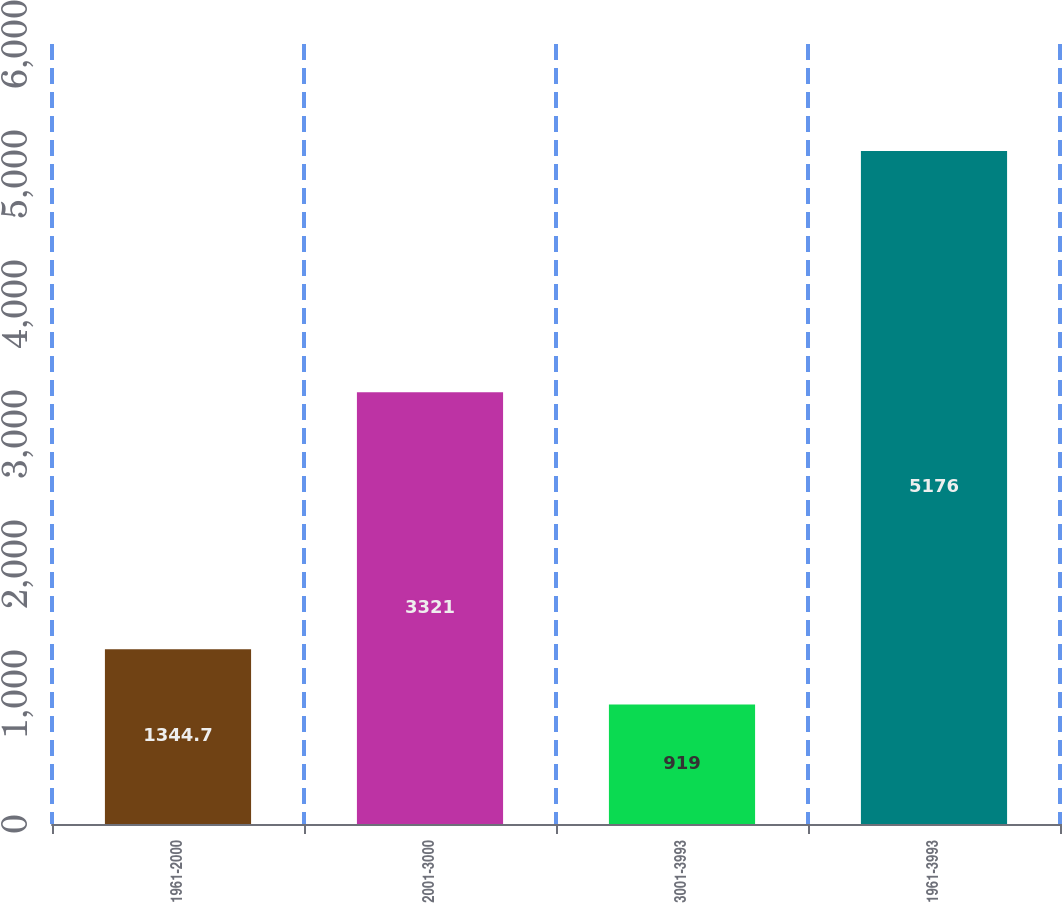<chart> <loc_0><loc_0><loc_500><loc_500><bar_chart><fcel>1961-2000<fcel>2001-3000<fcel>3001-3993<fcel>1961-3993<nl><fcel>1344.7<fcel>3321<fcel>919<fcel>5176<nl></chart> 